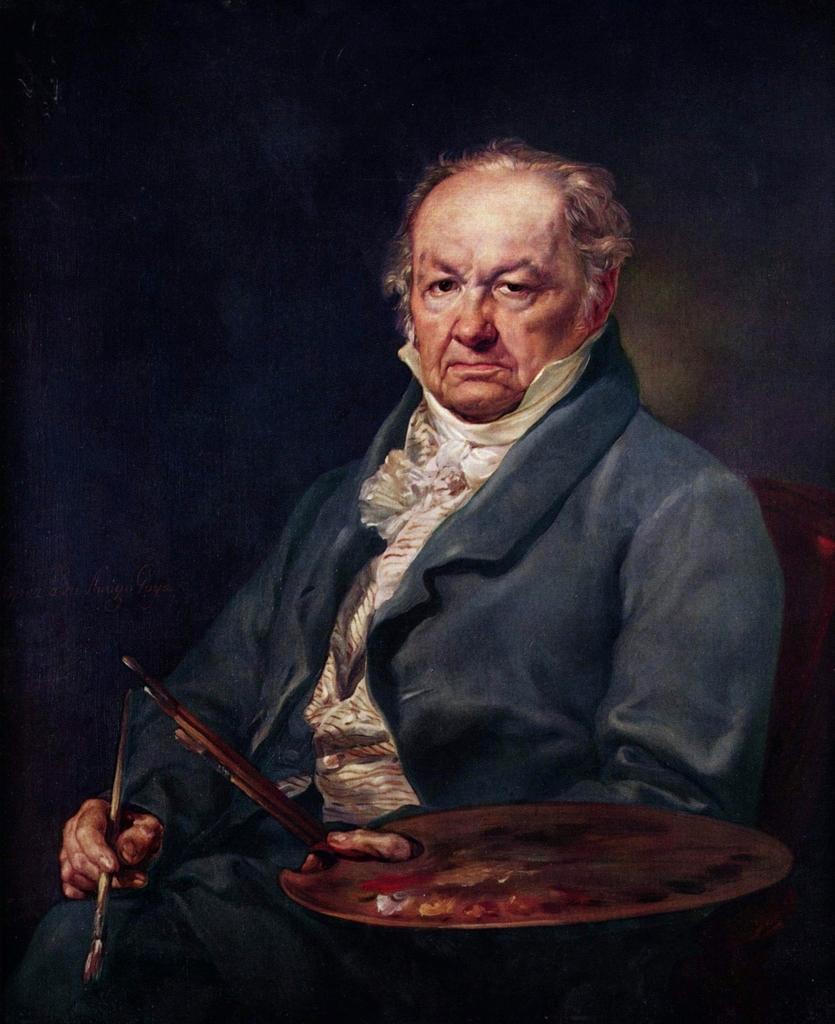Can you describe this image briefly? In this picture we can see a man sitting and holding a paintbrush, paint palette with his hands and in the background it is dark. 